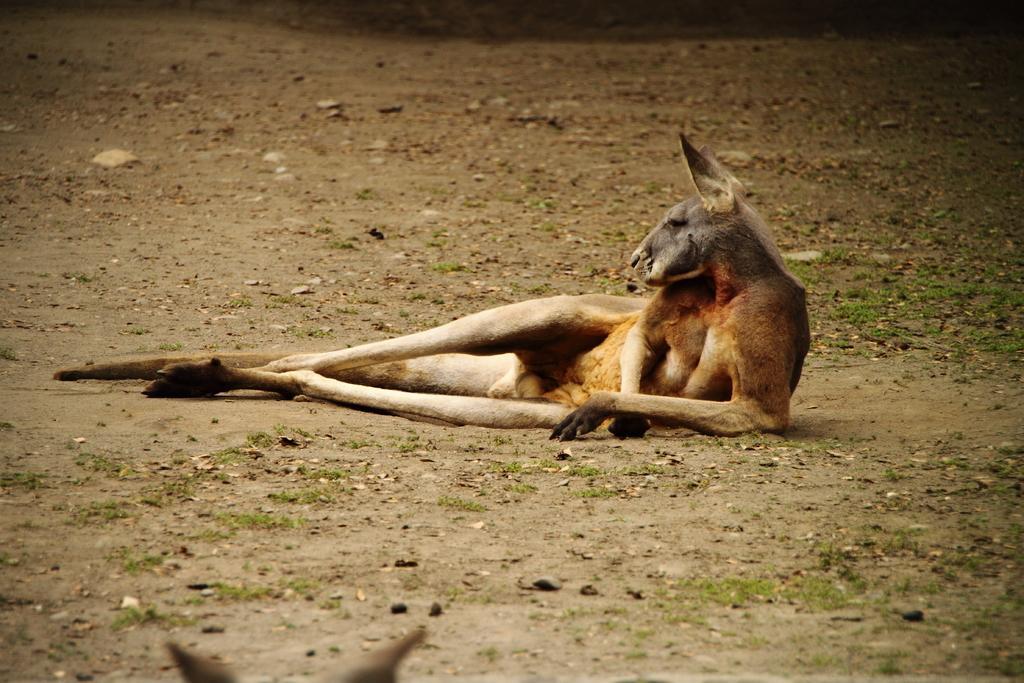Please provide a concise description of this image. In this picture we can see an animal on the ground. 